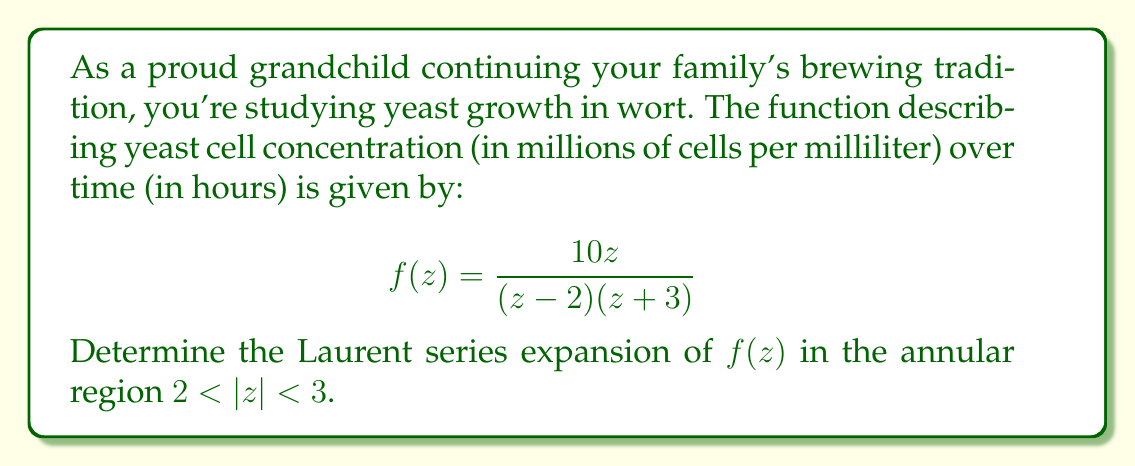Could you help me with this problem? To find the Laurent series expansion of $f(z)$ in the annular region $2 < |z| < 3$, we need to follow these steps:

1) First, we need to decompose $f(z)$ into partial fractions:

   $$f(z) = \frac{10z}{(z-2)(z+3)} = \frac{A}{z-2} + \frac{B}{z+3}$$

2) To find A and B, we multiply both sides by $(z-2)(z+3)$:

   $10z = A(z+3) + B(z-2)$

3) Substituting $z=2$ and $z=-3$, we get:

   $20 = 5A$, so $A=4$
   $-30 = -5B$, so $B=6$

4) Therefore, our partial fraction decomposition is:

   $$f(z) = \frac{4}{z-2} + \frac{6}{z+3}$$

5) Now, we need to expand each term separately:

   For $\frac{4}{z-2}$, we can use the geometric series $\frac{1}{1-x} = 1 + x + x^2 + ...$
   Let $x = \frac{2}{z}$, then:

   $$\frac{4}{z-2} = -\frac{4}{2} \cdot \frac{1}{1-\frac{z}{2}} = -2 \sum_{n=0}^{\infty} \left(\frac{z}{2}\right)^n = -2 \sum_{n=0}^{\infty} \frac{z^n}{2^n}$$

   For $\frac{6}{z+3}$, we can directly use the binomial series $(1+x)^{-1} = 1 - x + x^2 - ...$
   Let $x = -\frac{3}{z}$, then:

   $$\frac{6}{z+3} = \frac{6}{z} \cdot \frac{1}{1-\frac{3}{z}} = \frac{6}{z} \sum_{n=0}^{\infty} \left(-\frac{3}{z}\right)^n = 6 \sum_{n=0}^{\infty} \frac{(-3)^n}{z^{n+1}}$$

6) Combining these series:

   $$f(z) = -2 \sum_{n=0}^{\infty} \frac{z^n}{2^n} + 6 \sum_{n=0}^{\infty} \frac{(-3)^n}{z^{n+1}}$$

This is the Laurent series expansion of $f(z)$ in the annular region $2 < |z| < 3$.
Answer: $$f(z) = -2 \sum_{n=0}^{\infty} \frac{z^n}{2^n} + 6 \sum_{n=0}^{\infty} \frac{(-3)^n}{z^{n+1}}$$ 